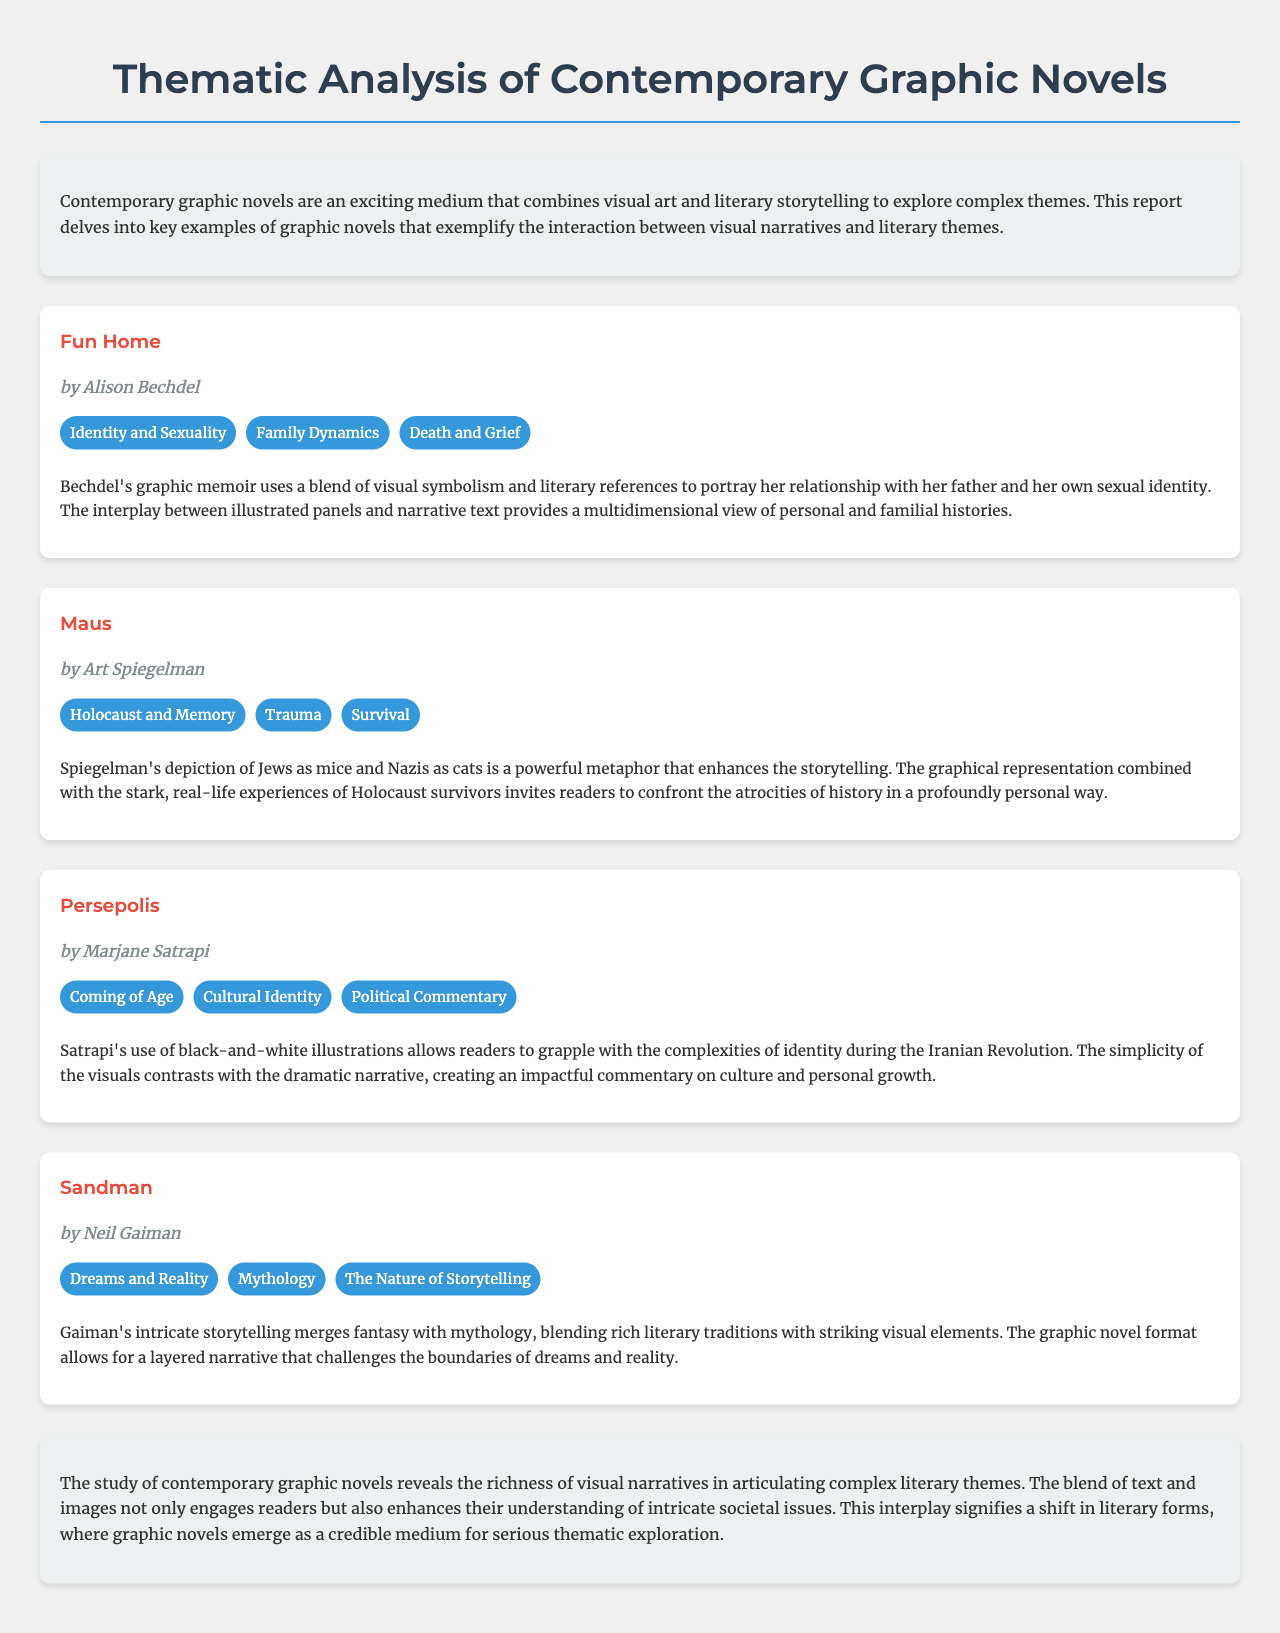What is the title of the report? The title of the report is indicated at the top of the document.
Answer: Thematic Analysis of Contemporary Graphic Novels Who is the author of "Fun Home"? The author is mentioned below the title of the novel in the document.
Answer: Alison Bechdel What theme is associated with "Maus"? The themes are listed beside the title of the novel.
Answer: Holocaust and Memory What visual style does Marjane Satrapi use in "Persepolis"? The analysis section describes the visual approach of the graphic novel.
Answer: Black-and-white illustrations How many themes are listed for "Sandman"? The number of themes can be counted from the specified section in the document.
Answer: Three Which graphic novel addresses "Coming of Age"? The themes associated with each novel identify the primary focus.
Answer: Persepolis What narrative technique is highlighted in "Maus"? The analysis provides insight into the storytelling method used.
Answer: Metaphor What societal issue does the conclusion discuss? The conclusion sums up the themes explored in the document regarding graphic novels.
Answer: Complex literary themes 